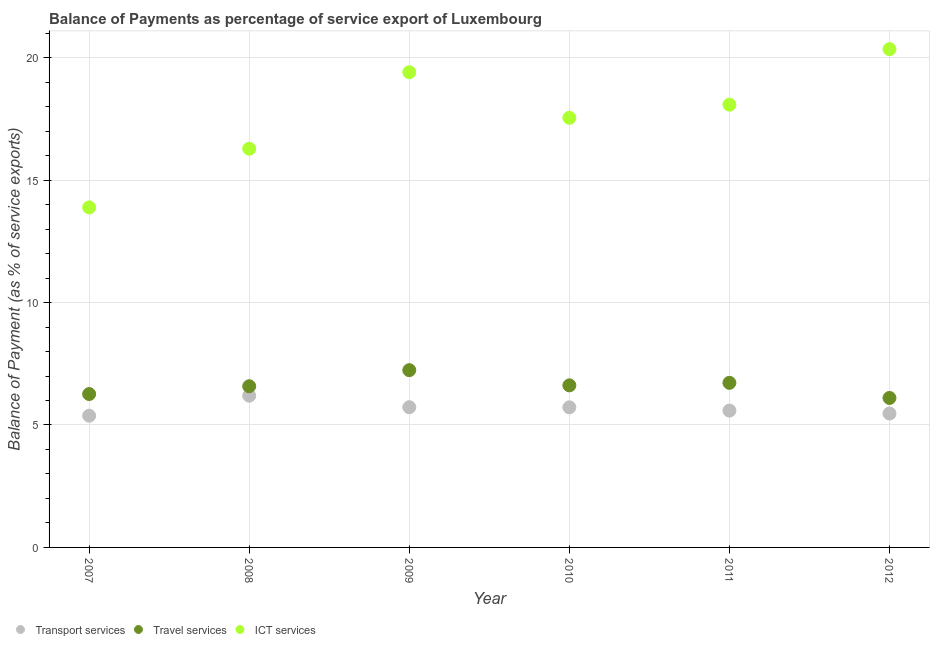Is the number of dotlines equal to the number of legend labels?
Your answer should be compact. Yes. What is the balance of payment of transport services in 2009?
Give a very brief answer. 5.73. Across all years, what is the maximum balance of payment of ict services?
Offer a very short reply. 20.35. Across all years, what is the minimum balance of payment of transport services?
Provide a succinct answer. 5.38. In which year was the balance of payment of ict services maximum?
Ensure brevity in your answer.  2012. What is the total balance of payment of travel services in the graph?
Ensure brevity in your answer.  39.53. What is the difference between the balance of payment of transport services in 2010 and that in 2011?
Make the answer very short. 0.13. What is the difference between the balance of payment of transport services in 2010 and the balance of payment of ict services in 2012?
Offer a very short reply. -14.63. What is the average balance of payment of ict services per year?
Provide a succinct answer. 17.59. In the year 2008, what is the difference between the balance of payment of ict services and balance of payment of transport services?
Make the answer very short. 10.09. What is the ratio of the balance of payment of ict services in 2010 to that in 2011?
Make the answer very short. 0.97. Is the balance of payment of transport services in 2008 less than that in 2012?
Your response must be concise. No. Is the difference between the balance of payment of transport services in 2009 and 2012 greater than the difference between the balance of payment of travel services in 2009 and 2012?
Make the answer very short. No. What is the difference between the highest and the second highest balance of payment of transport services?
Ensure brevity in your answer.  0.47. What is the difference between the highest and the lowest balance of payment of travel services?
Provide a succinct answer. 1.13. In how many years, is the balance of payment of ict services greater than the average balance of payment of ict services taken over all years?
Give a very brief answer. 3. Is the balance of payment of transport services strictly less than the balance of payment of ict services over the years?
Your answer should be very brief. Yes. How many dotlines are there?
Offer a terse response. 3. How many years are there in the graph?
Your response must be concise. 6. Are the values on the major ticks of Y-axis written in scientific E-notation?
Keep it short and to the point. No. Does the graph contain any zero values?
Offer a very short reply. No. What is the title of the graph?
Offer a very short reply. Balance of Payments as percentage of service export of Luxembourg. What is the label or title of the X-axis?
Provide a succinct answer. Year. What is the label or title of the Y-axis?
Provide a short and direct response. Balance of Payment (as % of service exports). What is the Balance of Payment (as % of service exports) of Transport services in 2007?
Offer a very short reply. 5.38. What is the Balance of Payment (as % of service exports) of Travel services in 2007?
Provide a short and direct response. 6.26. What is the Balance of Payment (as % of service exports) of ICT services in 2007?
Provide a short and direct response. 13.89. What is the Balance of Payment (as % of service exports) in Transport services in 2008?
Ensure brevity in your answer.  6.2. What is the Balance of Payment (as % of service exports) of Travel services in 2008?
Provide a short and direct response. 6.58. What is the Balance of Payment (as % of service exports) in ICT services in 2008?
Offer a terse response. 16.28. What is the Balance of Payment (as % of service exports) of Transport services in 2009?
Your answer should be very brief. 5.73. What is the Balance of Payment (as % of service exports) in Travel services in 2009?
Make the answer very short. 7.24. What is the Balance of Payment (as % of service exports) of ICT services in 2009?
Provide a succinct answer. 19.41. What is the Balance of Payment (as % of service exports) of Transport services in 2010?
Provide a succinct answer. 5.72. What is the Balance of Payment (as % of service exports) of Travel services in 2010?
Ensure brevity in your answer.  6.62. What is the Balance of Payment (as % of service exports) of ICT services in 2010?
Provide a succinct answer. 17.55. What is the Balance of Payment (as % of service exports) of Transport services in 2011?
Provide a succinct answer. 5.59. What is the Balance of Payment (as % of service exports) in Travel services in 2011?
Provide a short and direct response. 6.72. What is the Balance of Payment (as % of service exports) of ICT services in 2011?
Ensure brevity in your answer.  18.08. What is the Balance of Payment (as % of service exports) in Transport services in 2012?
Keep it short and to the point. 5.47. What is the Balance of Payment (as % of service exports) of Travel services in 2012?
Your response must be concise. 6.11. What is the Balance of Payment (as % of service exports) of ICT services in 2012?
Ensure brevity in your answer.  20.35. Across all years, what is the maximum Balance of Payment (as % of service exports) of Transport services?
Give a very brief answer. 6.2. Across all years, what is the maximum Balance of Payment (as % of service exports) of Travel services?
Your answer should be very brief. 7.24. Across all years, what is the maximum Balance of Payment (as % of service exports) in ICT services?
Your answer should be compact. 20.35. Across all years, what is the minimum Balance of Payment (as % of service exports) in Transport services?
Offer a very short reply. 5.38. Across all years, what is the minimum Balance of Payment (as % of service exports) in Travel services?
Your response must be concise. 6.11. Across all years, what is the minimum Balance of Payment (as % of service exports) in ICT services?
Keep it short and to the point. 13.89. What is the total Balance of Payment (as % of service exports) in Transport services in the graph?
Provide a short and direct response. 34.08. What is the total Balance of Payment (as % of service exports) of Travel services in the graph?
Offer a terse response. 39.53. What is the total Balance of Payment (as % of service exports) of ICT services in the graph?
Your answer should be compact. 105.56. What is the difference between the Balance of Payment (as % of service exports) of Transport services in 2007 and that in 2008?
Your response must be concise. -0.82. What is the difference between the Balance of Payment (as % of service exports) of Travel services in 2007 and that in 2008?
Your answer should be compact. -0.32. What is the difference between the Balance of Payment (as % of service exports) in ICT services in 2007 and that in 2008?
Keep it short and to the point. -2.4. What is the difference between the Balance of Payment (as % of service exports) of Transport services in 2007 and that in 2009?
Offer a very short reply. -0.35. What is the difference between the Balance of Payment (as % of service exports) in Travel services in 2007 and that in 2009?
Ensure brevity in your answer.  -0.98. What is the difference between the Balance of Payment (as % of service exports) in ICT services in 2007 and that in 2009?
Offer a very short reply. -5.52. What is the difference between the Balance of Payment (as % of service exports) of Transport services in 2007 and that in 2010?
Provide a succinct answer. -0.34. What is the difference between the Balance of Payment (as % of service exports) of Travel services in 2007 and that in 2010?
Provide a succinct answer. -0.35. What is the difference between the Balance of Payment (as % of service exports) of ICT services in 2007 and that in 2010?
Offer a terse response. -3.66. What is the difference between the Balance of Payment (as % of service exports) in Transport services in 2007 and that in 2011?
Give a very brief answer. -0.21. What is the difference between the Balance of Payment (as % of service exports) of Travel services in 2007 and that in 2011?
Offer a terse response. -0.46. What is the difference between the Balance of Payment (as % of service exports) in ICT services in 2007 and that in 2011?
Your response must be concise. -4.2. What is the difference between the Balance of Payment (as % of service exports) of Transport services in 2007 and that in 2012?
Your response must be concise. -0.09. What is the difference between the Balance of Payment (as % of service exports) of Travel services in 2007 and that in 2012?
Keep it short and to the point. 0.16. What is the difference between the Balance of Payment (as % of service exports) in ICT services in 2007 and that in 2012?
Offer a very short reply. -6.46. What is the difference between the Balance of Payment (as % of service exports) of Transport services in 2008 and that in 2009?
Your response must be concise. 0.47. What is the difference between the Balance of Payment (as % of service exports) of Travel services in 2008 and that in 2009?
Give a very brief answer. -0.66. What is the difference between the Balance of Payment (as % of service exports) in ICT services in 2008 and that in 2009?
Provide a succinct answer. -3.12. What is the difference between the Balance of Payment (as % of service exports) in Transport services in 2008 and that in 2010?
Your answer should be compact. 0.47. What is the difference between the Balance of Payment (as % of service exports) of Travel services in 2008 and that in 2010?
Provide a succinct answer. -0.04. What is the difference between the Balance of Payment (as % of service exports) in ICT services in 2008 and that in 2010?
Your answer should be very brief. -1.26. What is the difference between the Balance of Payment (as % of service exports) in Transport services in 2008 and that in 2011?
Offer a terse response. 0.61. What is the difference between the Balance of Payment (as % of service exports) in Travel services in 2008 and that in 2011?
Your answer should be compact. -0.14. What is the difference between the Balance of Payment (as % of service exports) of ICT services in 2008 and that in 2011?
Provide a short and direct response. -1.8. What is the difference between the Balance of Payment (as % of service exports) in Transport services in 2008 and that in 2012?
Give a very brief answer. 0.73. What is the difference between the Balance of Payment (as % of service exports) of Travel services in 2008 and that in 2012?
Your answer should be very brief. 0.48. What is the difference between the Balance of Payment (as % of service exports) of ICT services in 2008 and that in 2012?
Make the answer very short. -4.07. What is the difference between the Balance of Payment (as % of service exports) of Transport services in 2009 and that in 2010?
Offer a very short reply. 0. What is the difference between the Balance of Payment (as % of service exports) of Travel services in 2009 and that in 2010?
Offer a terse response. 0.62. What is the difference between the Balance of Payment (as % of service exports) in ICT services in 2009 and that in 2010?
Your response must be concise. 1.86. What is the difference between the Balance of Payment (as % of service exports) in Transport services in 2009 and that in 2011?
Provide a succinct answer. 0.14. What is the difference between the Balance of Payment (as % of service exports) of Travel services in 2009 and that in 2011?
Offer a terse response. 0.52. What is the difference between the Balance of Payment (as % of service exports) in ICT services in 2009 and that in 2011?
Provide a succinct answer. 1.33. What is the difference between the Balance of Payment (as % of service exports) in Transport services in 2009 and that in 2012?
Your answer should be very brief. 0.26. What is the difference between the Balance of Payment (as % of service exports) of Travel services in 2009 and that in 2012?
Keep it short and to the point. 1.13. What is the difference between the Balance of Payment (as % of service exports) of ICT services in 2009 and that in 2012?
Provide a succinct answer. -0.94. What is the difference between the Balance of Payment (as % of service exports) of Transport services in 2010 and that in 2011?
Your answer should be compact. 0.13. What is the difference between the Balance of Payment (as % of service exports) in Travel services in 2010 and that in 2011?
Offer a very short reply. -0.1. What is the difference between the Balance of Payment (as % of service exports) in ICT services in 2010 and that in 2011?
Your answer should be very brief. -0.54. What is the difference between the Balance of Payment (as % of service exports) of Transport services in 2010 and that in 2012?
Your answer should be compact. 0.25. What is the difference between the Balance of Payment (as % of service exports) of Travel services in 2010 and that in 2012?
Provide a short and direct response. 0.51. What is the difference between the Balance of Payment (as % of service exports) of ICT services in 2010 and that in 2012?
Provide a succinct answer. -2.8. What is the difference between the Balance of Payment (as % of service exports) of Transport services in 2011 and that in 2012?
Provide a succinct answer. 0.12. What is the difference between the Balance of Payment (as % of service exports) in Travel services in 2011 and that in 2012?
Give a very brief answer. 0.62. What is the difference between the Balance of Payment (as % of service exports) in ICT services in 2011 and that in 2012?
Offer a very short reply. -2.27. What is the difference between the Balance of Payment (as % of service exports) of Transport services in 2007 and the Balance of Payment (as % of service exports) of Travel services in 2008?
Your response must be concise. -1.2. What is the difference between the Balance of Payment (as % of service exports) in Transport services in 2007 and the Balance of Payment (as % of service exports) in ICT services in 2008?
Your response must be concise. -10.9. What is the difference between the Balance of Payment (as % of service exports) of Travel services in 2007 and the Balance of Payment (as % of service exports) of ICT services in 2008?
Offer a very short reply. -10.02. What is the difference between the Balance of Payment (as % of service exports) of Transport services in 2007 and the Balance of Payment (as % of service exports) of Travel services in 2009?
Offer a terse response. -1.86. What is the difference between the Balance of Payment (as % of service exports) of Transport services in 2007 and the Balance of Payment (as % of service exports) of ICT services in 2009?
Ensure brevity in your answer.  -14.03. What is the difference between the Balance of Payment (as % of service exports) in Travel services in 2007 and the Balance of Payment (as % of service exports) in ICT services in 2009?
Ensure brevity in your answer.  -13.14. What is the difference between the Balance of Payment (as % of service exports) in Transport services in 2007 and the Balance of Payment (as % of service exports) in Travel services in 2010?
Make the answer very short. -1.24. What is the difference between the Balance of Payment (as % of service exports) in Transport services in 2007 and the Balance of Payment (as % of service exports) in ICT services in 2010?
Offer a terse response. -12.17. What is the difference between the Balance of Payment (as % of service exports) of Travel services in 2007 and the Balance of Payment (as % of service exports) of ICT services in 2010?
Offer a terse response. -11.28. What is the difference between the Balance of Payment (as % of service exports) of Transport services in 2007 and the Balance of Payment (as % of service exports) of Travel services in 2011?
Provide a short and direct response. -1.34. What is the difference between the Balance of Payment (as % of service exports) of Transport services in 2007 and the Balance of Payment (as % of service exports) of ICT services in 2011?
Offer a terse response. -12.7. What is the difference between the Balance of Payment (as % of service exports) in Travel services in 2007 and the Balance of Payment (as % of service exports) in ICT services in 2011?
Provide a succinct answer. -11.82. What is the difference between the Balance of Payment (as % of service exports) of Transport services in 2007 and the Balance of Payment (as % of service exports) of Travel services in 2012?
Your answer should be very brief. -0.73. What is the difference between the Balance of Payment (as % of service exports) of Transport services in 2007 and the Balance of Payment (as % of service exports) of ICT services in 2012?
Provide a succinct answer. -14.97. What is the difference between the Balance of Payment (as % of service exports) of Travel services in 2007 and the Balance of Payment (as % of service exports) of ICT services in 2012?
Your response must be concise. -14.09. What is the difference between the Balance of Payment (as % of service exports) in Transport services in 2008 and the Balance of Payment (as % of service exports) in Travel services in 2009?
Ensure brevity in your answer.  -1.04. What is the difference between the Balance of Payment (as % of service exports) in Transport services in 2008 and the Balance of Payment (as % of service exports) in ICT services in 2009?
Ensure brevity in your answer.  -13.21. What is the difference between the Balance of Payment (as % of service exports) in Travel services in 2008 and the Balance of Payment (as % of service exports) in ICT services in 2009?
Provide a short and direct response. -12.82. What is the difference between the Balance of Payment (as % of service exports) in Transport services in 2008 and the Balance of Payment (as % of service exports) in Travel services in 2010?
Your response must be concise. -0.42. What is the difference between the Balance of Payment (as % of service exports) in Transport services in 2008 and the Balance of Payment (as % of service exports) in ICT services in 2010?
Make the answer very short. -11.35. What is the difference between the Balance of Payment (as % of service exports) in Travel services in 2008 and the Balance of Payment (as % of service exports) in ICT services in 2010?
Provide a succinct answer. -10.96. What is the difference between the Balance of Payment (as % of service exports) of Transport services in 2008 and the Balance of Payment (as % of service exports) of Travel services in 2011?
Ensure brevity in your answer.  -0.53. What is the difference between the Balance of Payment (as % of service exports) of Transport services in 2008 and the Balance of Payment (as % of service exports) of ICT services in 2011?
Your answer should be very brief. -11.89. What is the difference between the Balance of Payment (as % of service exports) in Travel services in 2008 and the Balance of Payment (as % of service exports) in ICT services in 2011?
Ensure brevity in your answer.  -11.5. What is the difference between the Balance of Payment (as % of service exports) of Transport services in 2008 and the Balance of Payment (as % of service exports) of Travel services in 2012?
Offer a very short reply. 0.09. What is the difference between the Balance of Payment (as % of service exports) of Transport services in 2008 and the Balance of Payment (as % of service exports) of ICT services in 2012?
Your response must be concise. -14.15. What is the difference between the Balance of Payment (as % of service exports) of Travel services in 2008 and the Balance of Payment (as % of service exports) of ICT services in 2012?
Make the answer very short. -13.77. What is the difference between the Balance of Payment (as % of service exports) in Transport services in 2009 and the Balance of Payment (as % of service exports) in Travel services in 2010?
Offer a terse response. -0.89. What is the difference between the Balance of Payment (as % of service exports) in Transport services in 2009 and the Balance of Payment (as % of service exports) in ICT services in 2010?
Offer a terse response. -11.82. What is the difference between the Balance of Payment (as % of service exports) of Travel services in 2009 and the Balance of Payment (as % of service exports) of ICT services in 2010?
Offer a very short reply. -10.31. What is the difference between the Balance of Payment (as % of service exports) of Transport services in 2009 and the Balance of Payment (as % of service exports) of Travel services in 2011?
Your response must be concise. -1. What is the difference between the Balance of Payment (as % of service exports) of Transport services in 2009 and the Balance of Payment (as % of service exports) of ICT services in 2011?
Provide a succinct answer. -12.36. What is the difference between the Balance of Payment (as % of service exports) of Travel services in 2009 and the Balance of Payment (as % of service exports) of ICT services in 2011?
Make the answer very short. -10.84. What is the difference between the Balance of Payment (as % of service exports) of Transport services in 2009 and the Balance of Payment (as % of service exports) of Travel services in 2012?
Keep it short and to the point. -0.38. What is the difference between the Balance of Payment (as % of service exports) of Transport services in 2009 and the Balance of Payment (as % of service exports) of ICT services in 2012?
Make the answer very short. -14.62. What is the difference between the Balance of Payment (as % of service exports) in Travel services in 2009 and the Balance of Payment (as % of service exports) in ICT services in 2012?
Give a very brief answer. -13.11. What is the difference between the Balance of Payment (as % of service exports) in Transport services in 2010 and the Balance of Payment (as % of service exports) in Travel services in 2011?
Keep it short and to the point. -1. What is the difference between the Balance of Payment (as % of service exports) in Transport services in 2010 and the Balance of Payment (as % of service exports) in ICT services in 2011?
Ensure brevity in your answer.  -12.36. What is the difference between the Balance of Payment (as % of service exports) in Travel services in 2010 and the Balance of Payment (as % of service exports) in ICT services in 2011?
Your answer should be compact. -11.46. What is the difference between the Balance of Payment (as % of service exports) in Transport services in 2010 and the Balance of Payment (as % of service exports) in Travel services in 2012?
Your answer should be very brief. -0.38. What is the difference between the Balance of Payment (as % of service exports) of Transport services in 2010 and the Balance of Payment (as % of service exports) of ICT services in 2012?
Ensure brevity in your answer.  -14.63. What is the difference between the Balance of Payment (as % of service exports) in Travel services in 2010 and the Balance of Payment (as % of service exports) in ICT services in 2012?
Keep it short and to the point. -13.73. What is the difference between the Balance of Payment (as % of service exports) of Transport services in 2011 and the Balance of Payment (as % of service exports) of Travel services in 2012?
Your answer should be compact. -0.52. What is the difference between the Balance of Payment (as % of service exports) in Transport services in 2011 and the Balance of Payment (as % of service exports) in ICT services in 2012?
Offer a very short reply. -14.76. What is the difference between the Balance of Payment (as % of service exports) in Travel services in 2011 and the Balance of Payment (as % of service exports) in ICT services in 2012?
Provide a succinct answer. -13.63. What is the average Balance of Payment (as % of service exports) of Transport services per year?
Offer a very short reply. 5.68. What is the average Balance of Payment (as % of service exports) of Travel services per year?
Offer a terse response. 6.59. What is the average Balance of Payment (as % of service exports) in ICT services per year?
Provide a short and direct response. 17.59. In the year 2007, what is the difference between the Balance of Payment (as % of service exports) in Transport services and Balance of Payment (as % of service exports) in Travel services?
Give a very brief answer. -0.89. In the year 2007, what is the difference between the Balance of Payment (as % of service exports) of Transport services and Balance of Payment (as % of service exports) of ICT services?
Provide a succinct answer. -8.51. In the year 2007, what is the difference between the Balance of Payment (as % of service exports) in Travel services and Balance of Payment (as % of service exports) in ICT services?
Give a very brief answer. -7.62. In the year 2008, what is the difference between the Balance of Payment (as % of service exports) in Transport services and Balance of Payment (as % of service exports) in Travel services?
Your answer should be very brief. -0.39. In the year 2008, what is the difference between the Balance of Payment (as % of service exports) in Transport services and Balance of Payment (as % of service exports) in ICT services?
Offer a terse response. -10.09. In the year 2008, what is the difference between the Balance of Payment (as % of service exports) of Travel services and Balance of Payment (as % of service exports) of ICT services?
Make the answer very short. -9.7. In the year 2009, what is the difference between the Balance of Payment (as % of service exports) of Transport services and Balance of Payment (as % of service exports) of Travel services?
Ensure brevity in your answer.  -1.51. In the year 2009, what is the difference between the Balance of Payment (as % of service exports) in Transport services and Balance of Payment (as % of service exports) in ICT services?
Make the answer very short. -13.68. In the year 2009, what is the difference between the Balance of Payment (as % of service exports) in Travel services and Balance of Payment (as % of service exports) in ICT services?
Provide a short and direct response. -12.17. In the year 2010, what is the difference between the Balance of Payment (as % of service exports) of Transport services and Balance of Payment (as % of service exports) of Travel services?
Provide a short and direct response. -0.9. In the year 2010, what is the difference between the Balance of Payment (as % of service exports) of Transport services and Balance of Payment (as % of service exports) of ICT services?
Your answer should be very brief. -11.82. In the year 2010, what is the difference between the Balance of Payment (as % of service exports) of Travel services and Balance of Payment (as % of service exports) of ICT services?
Provide a succinct answer. -10.93. In the year 2011, what is the difference between the Balance of Payment (as % of service exports) of Transport services and Balance of Payment (as % of service exports) of Travel services?
Your answer should be compact. -1.13. In the year 2011, what is the difference between the Balance of Payment (as % of service exports) in Transport services and Balance of Payment (as % of service exports) in ICT services?
Make the answer very short. -12.49. In the year 2011, what is the difference between the Balance of Payment (as % of service exports) in Travel services and Balance of Payment (as % of service exports) in ICT services?
Your response must be concise. -11.36. In the year 2012, what is the difference between the Balance of Payment (as % of service exports) in Transport services and Balance of Payment (as % of service exports) in Travel services?
Provide a short and direct response. -0.64. In the year 2012, what is the difference between the Balance of Payment (as % of service exports) of Transport services and Balance of Payment (as % of service exports) of ICT services?
Provide a short and direct response. -14.88. In the year 2012, what is the difference between the Balance of Payment (as % of service exports) of Travel services and Balance of Payment (as % of service exports) of ICT services?
Your response must be concise. -14.24. What is the ratio of the Balance of Payment (as % of service exports) in Transport services in 2007 to that in 2008?
Make the answer very short. 0.87. What is the ratio of the Balance of Payment (as % of service exports) in Travel services in 2007 to that in 2008?
Provide a succinct answer. 0.95. What is the ratio of the Balance of Payment (as % of service exports) in ICT services in 2007 to that in 2008?
Keep it short and to the point. 0.85. What is the ratio of the Balance of Payment (as % of service exports) in Transport services in 2007 to that in 2009?
Give a very brief answer. 0.94. What is the ratio of the Balance of Payment (as % of service exports) of Travel services in 2007 to that in 2009?
Ensure brevity in your answer.  0.87. What is the ratio of the Balance of Payment (as % of service exports) of ICT services in 2007 to that in 2009?
Your answer should be compact. 0.72. What is the ratio of the Balance of Payment (as % of service exports) of Transport services in 2007 to that in 2010?
Offer a terse response. 0.94. What is the ratio of the Balance of Payment (as % of service exports) of Travel services in 2007 to that in 2010?
Provide a succinct answer. 0.95. What is the ratio of the Balance of Payment (as % of service exports) of ICT services in 2007 to that in 2010?
Your answer should be very brief. 0.79. What is the ratio of the Balance of Payment (as % of service exports) of Transport services in 2007 to that in 2011?
Provide a succinct answer. 0.96. What is the ratio of the Balance of Payment (as % of service exports) of Travel services in 2007 to that in 2011?
Ensure brevity in your answer.  0.93. What is the ratio of the Balance of Payment (as % of service exports) of ICT services in 2007 to that in 2011?
Provide a short and direct response. 0.77. What is the ratio of the Balance of Payment (as % of service exports) of Transport services in 2007 to that in 2012?
Keep it short and to the point. 0.98. What is the ratio of the Balance of Payment (as % of service exports) of ICT services in 2007 to that in 2012?
Offer a very short reply. 0.68. What is the ratio of the Balance of Payment (as % of service exports) of Transport services in 2008 to that in 2009?
Provide a short and direct response. 1.08. What is the ratio of the Balance of Payment (as % of service exports) in Travel services in 2008 to that in 2009?
Your response must be concise. 0.91. What is the ratio of the Balance of Payment (as % of service exports) in ICT services in 2008 to that in 2009?
Provide a succinct answer. 0.84. What is the ratio of the Balance of Payment (as % of service exports) of Transport services in 2008 to that in 2010?
Make the answer very short. 1.08. What is the ratio of the Balance of Payment (as % of service exports) of Travel services in 2008 to that in 2010?
Keep it short and to the point. 0.99. What is the ratio of the Balance of Payment (as % of service exports) of ICT services in 2008 to that in 2010?
Provide a short and direct response. 0.93. What is the ratio of the Balance of Payment (as % of service exports) in Transport services in 2008 to that in 2011?
Give a very brief answer. 1.11. What is the ratio of the Balance of Payment (as % of service exports) of Travel services in 2008 to that in 2011?
Keep it short and to the point. 0.98. What is the ratio of the Balance of Payment (as % of service exports) in ICT services in 2008 to that in 2011?
Make the answer very short. 0.9. What is the ratio of the Balance of Payment (as % of service exports) of Transport services in 2008 to that in 2012?
Your answer should be very brief. 1.13. What is the ratio of the Balance of Payment (as % of service exports) in Travel services in 2008 to that in 2012?
Make the answer very short. 1.08. What is the ratio of the Balance of Payment (as % of service exports) of ICT services in 2008 to that in 2012?
Offer a very short reply. 0.8. What is the ratio of the Balance of Payment (as % of service exports) in Transport services in 2009 to that in 2010?
Your answer should be compact. 1. What is the ratio of the Balance of Payment (as % of service exports) in Travel services in 2009 to that in 2010?
Ensure brevity in your answer.  1.09. What is the ratio of the Balance of Payment (as % of service exports) in ICT services in 2009 to that in 2010?
Your response must be concise. 1.11. What is the ratio of the Balance of Payment (as % of service exports) of Transport services in 2009 to that in 2011?
Your answer should be very brief. 1.02. What is the ratio of the Balance of Payment (as % of service exports) in Travel services in 2009 to that in 2011?
Offer a very short reply. 1.08. What is the ratio of the Balance of Payment (as % of service exports) of ICT services in 2009 to that in 2011?
Your response must be concise. 1.07. What is the ratio of the Balance of Payment (as % of service exports) in Transport services in 2009 to that in 2012?
Provide a succinct answer. 1.05. What is the ratio of the Balance of Payment (as % of service exports) of Travel services in 2009 to that in 2012?
Give a very brief answer. 1.19. What is the ratio of the Balance of Payment (as % of service exports) of ICT services in 2009 to that in 2012?
Keep it short and to the point. 0.95. What is the ratio of the Balance of Payment (as % of service exports) in Transport services in 2010 to that in 2011?
Your response must be concise. 1.02. What is the ratio of the Balance of Payment (as % of service exports) in Travel services in 2010 to that in 2011?
Make the answer very short. 0.98. What is the ratio of the Balance of Payment (as % of service exports) of ICT services in 2010 to that in 2011?
Your response must be concise. 0.97. What is the ratio of the Balance of Payment (as % of service exports) of Transport services in 2010 to that in 2012?
Provide a short and direct response. 1.05. What is the ratio of the Balance of Payment (as % of service exports) of Travel services in 2010 to that in 2012?
Keep it short and to the point. 1.08. What is the ratio of the Balance of Payment (as % of service exports) of ICT services in 2010 to that in 2012?
Keep it short and to the point. 0.86. What is the ratio of the Balance of Payment (as % of service exports) in Transport services in 2011 to that in 2012?
Provide a short and direct response. 1.02. What is the ratio of the Balance of Payment (as % of service exports) of Travel services in 2011 to that in 2012?
Ensure brevity in your answer.  1.1. What is the ratio of the Balance of Payment (as % of service exports) in ICT services in 2011 to that in 2012?
Offer a terse response. 0.89. What is the difference between the highest and the second highest Balance of Payment (as % of service exports) of Transport services?
Keep it short and to the point. 0.47. What is the difference between the highest and the second highest Balance of Payment (as % of service exports) of Travel services?
Provide a succinct answer. 0.52. What is the difference between the highest and the second highest Balance of Payment (as % of service exports) of ICT services?
Provide a succinct answer. 0.94. What is the difference between the highest and the lowest Balance of Payment (as % of service exports) in Transport services?
Keep it short and to the point. 0.82. What is the difference between the highest and the lowest Balance of Payment (as % of service exports) of Travel services?
Your response must be concise. 1.13. What is the difference between the highest and the lowest Balance of Payment (as % of service exports) in ICT services?
Make the answer very short. 6.46. 